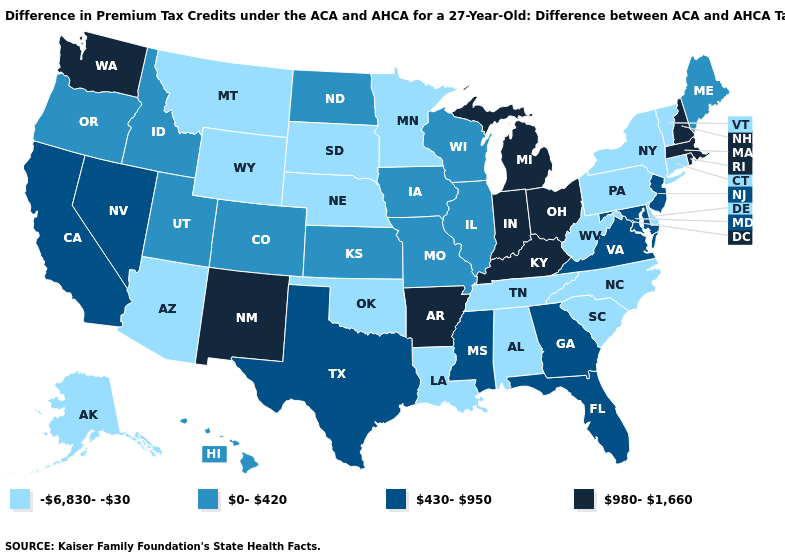What is the lowest value in states that border Iowa?
Keep it brief. -6,830--30. What is the highest value in the MidWest ?
Quick response, please. 980-1,660. Does Kentucky have the highest value in the South?
Answer briefly. Yes. Among the states that border Kansas , does Colorado have the highest value?
Give a very brief answer. Yes. Among the states that border Iowa , does South Dakota have the highest value?
Keep it brief. No. Does Georgia have the lowest value in the USA?
Answer briefly. No. What is the highest value in states that border Wyoming?
Be succinct. 0-420. What is the lowest value in the USA?
Write a very short answer. -6,830--30. Name the states that have a value in the range 980-1,660?
Short answer required. Arkansas, Indiana, Kentucky, Massachusetts, Michigan, New Hampshire, New Mexico, Ohio, Rhode Island, Washington. What is the highest value in the Northeast ?
Be succinct. 980-1,660. What is the value of Maryland?
Be succinct. 430-950. Which states hav the highest value in the West?
Give a very brief answer. New Mexico, Washington. What is the value of Georgia?
Answer briefly. 430-950. Does Idaho have the highest value in the West?
Write a very short answer. No. 